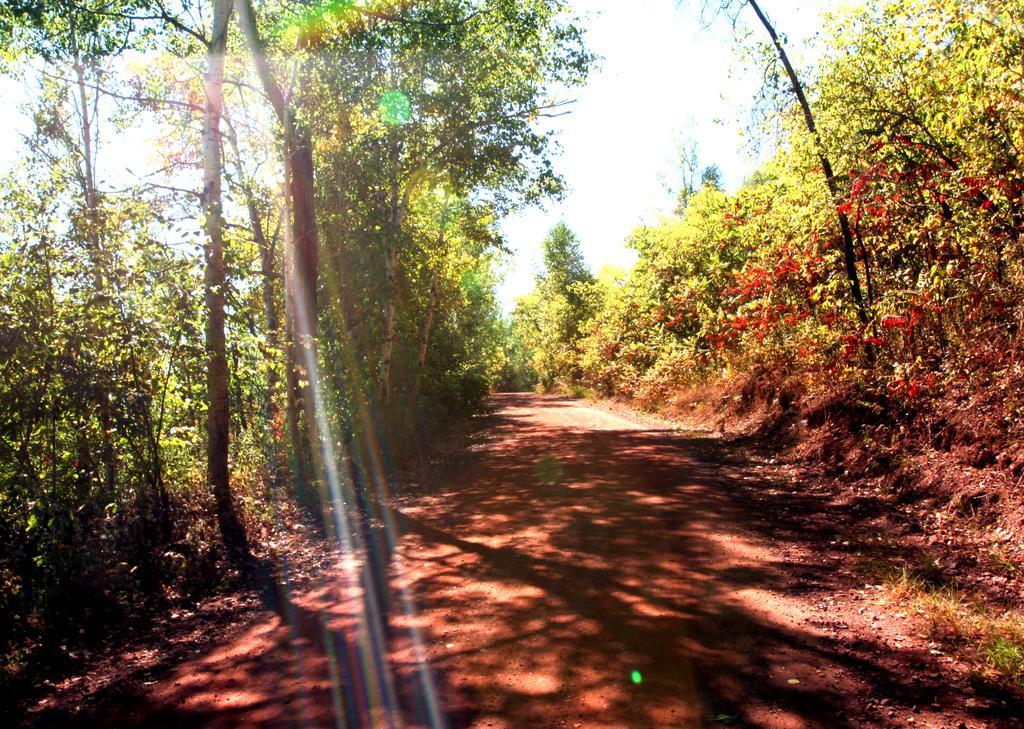How would you summarize this image in a sentence or two? In this image there is a path. On both sides of the path there are few plants and trees on the land. Background there is sky. 